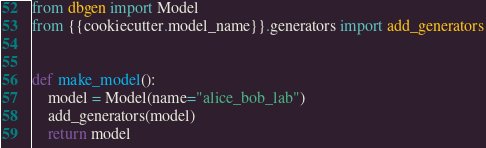Convert code to text. <code><loc_0><loc_0><loc_500><loc_500><_Python_>from dbgen import Model
from {{cookiecutter.model_name}}.generators import add_generators


def make_model():
    model = Model(name="alice_bob_lab")
    add_generators(model)
    return model
</code> 